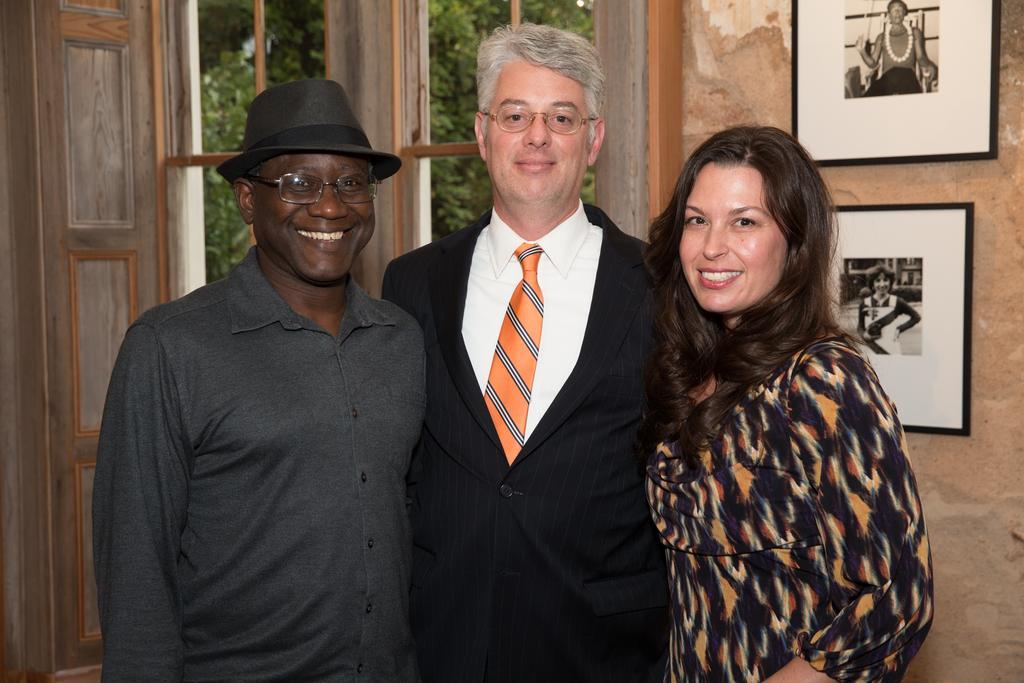How would you summarize this image in a sentence or two? In front of the image there are three people having a smile on their faces. Behind them there are photo frames on the wall. There is a window through which we can see trees. 